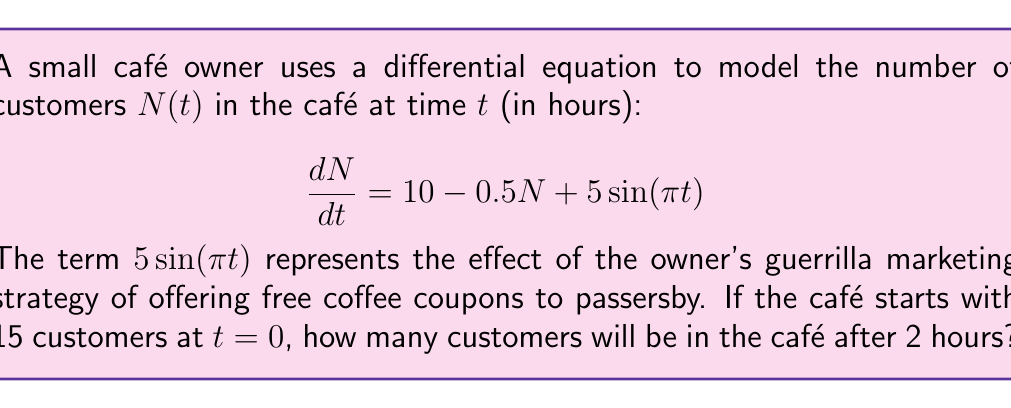Help me with this question. To solve this problem, we need to follow these steps:

1) The given differential equation is non-homogeneous and linear:

   $$\frac{dN}{dt} = 10 - 0.5N + 5\sin(\pi t)$$

2) The general solution to this equation is the sum of the complementary function (solution to the homogeneous equation) and a particular integral.

3) For the homogeneous part $\frac{dN}{dt} = -0.5N$, the solution is:

   $$N_h = Ce^{-0.5t}$$

4) For the particular integral, we guess a solution of the form:

   $$N_p = A + B\sin(\pi t) + C\cos(\pi t)$$

5) Substituting this into the original equation and solving for A, B, and C:

   $$A = 20, B = \frac{5\pi}{(\pi^2 + 0.25)}, C = \frac{2.5}{(\pi^2 + 0.25)}$$

6) The general solution is thus:

   $$N(t) = 20 + \frac{5\pi}{(\pi^2 + 0.25)}\sin(\pi t) + \frac{2.5}{(\pi^2 + 0.25)}\cos(\pi t) + Ce^{-0.5t}$$

7) Using the initial condition $N(0) = 15$, we can solve for C:

   $$15 = 20 + \frac{2.5}{(\pi^2 + 0.25)} + C$$
   $$C = -5 - \frac{2.5}{(\pi^2 + 0.25)}$$

8) Now we have the complete solution. To find N(2), we substitute t = 2:

   $$N(2) = 20 + \frac{5\pi}{(\pi^2 + 0.25)}\sin(2\pi) + \frac{2.5}{(\pi^2 + 0.25)}\cos(2\pi) + (-5 - \frac{2.5}{(\pi^2 + 0.25)})e^{-1}$$

9) Simplify, noting that $\sin(2\pi) = 0$ and $\cos(2\pi) = 1$:

   $$N(2) = 20 + \frac{2.5}{(\pi^2 + 0.25)} + (-5 - \frac{2.5}{(\pi^2 + 0.25)})e^{-1}$$

10) Calculate the final result:

    $$N(2) \approx 21.84$$
Answer: 22 customers (rounded to the nearest whole number) 